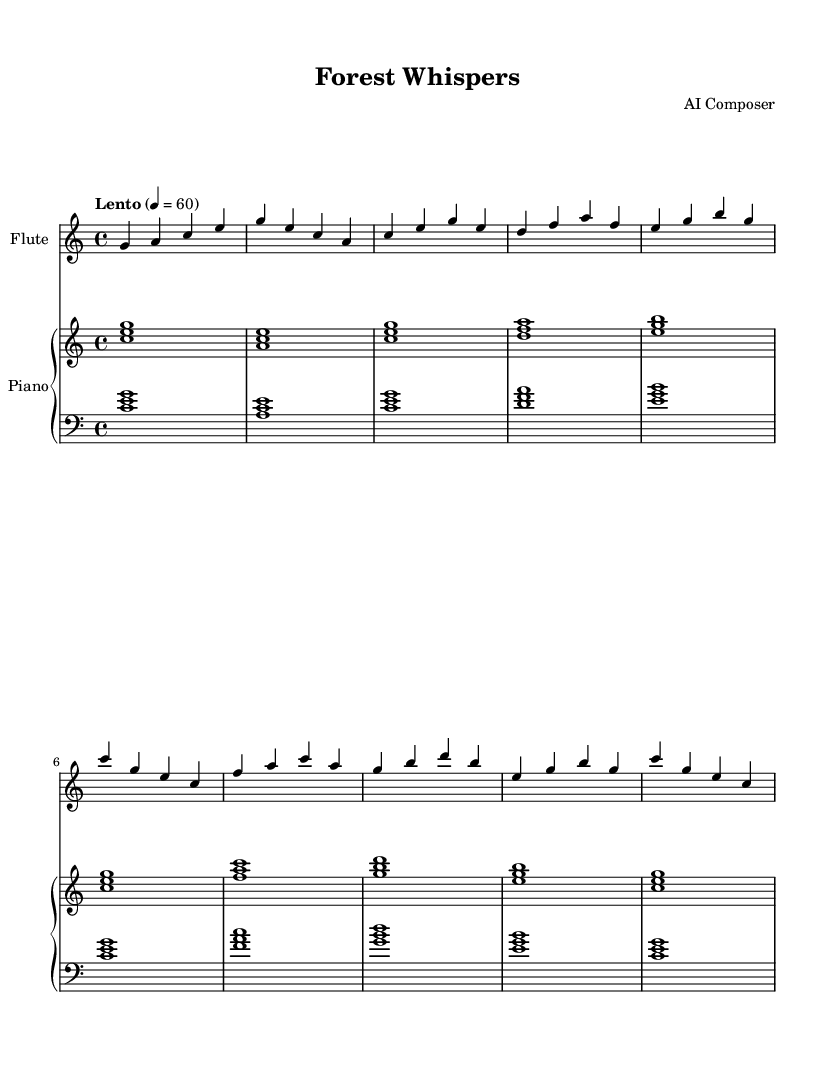What is the key signature of this music? The key signature is C major, which has no sharps or flats.
Answer: C major What is the time signature of this piece? The time signature is indicated right after the key signature, showing that there are four beats per measure.
Answer: 4/4 What is the tempo marking for this music? The tempo marking is indicated in the header section of the score, specifying a slow pace for this piece.
Answer: Lento How many measures are there in the A section? By counting the measures labeled under the A section, there are a total of four distinct measures.
Answer: 4 Which instrument performs the melody primarily? The flute part is the upper voice and plays the melody line throughout the piece.
Answer: Flute What harmonic intervals are used in the left hand of the piano during the intro? The left hand plays triadic intervals, which consist of three notes stacked together harmonically.
Answer: Triads Which section comes after the A section? The score is structured with sections labeled accordingly, and after the A section, the B section follows.
Answer: B section 